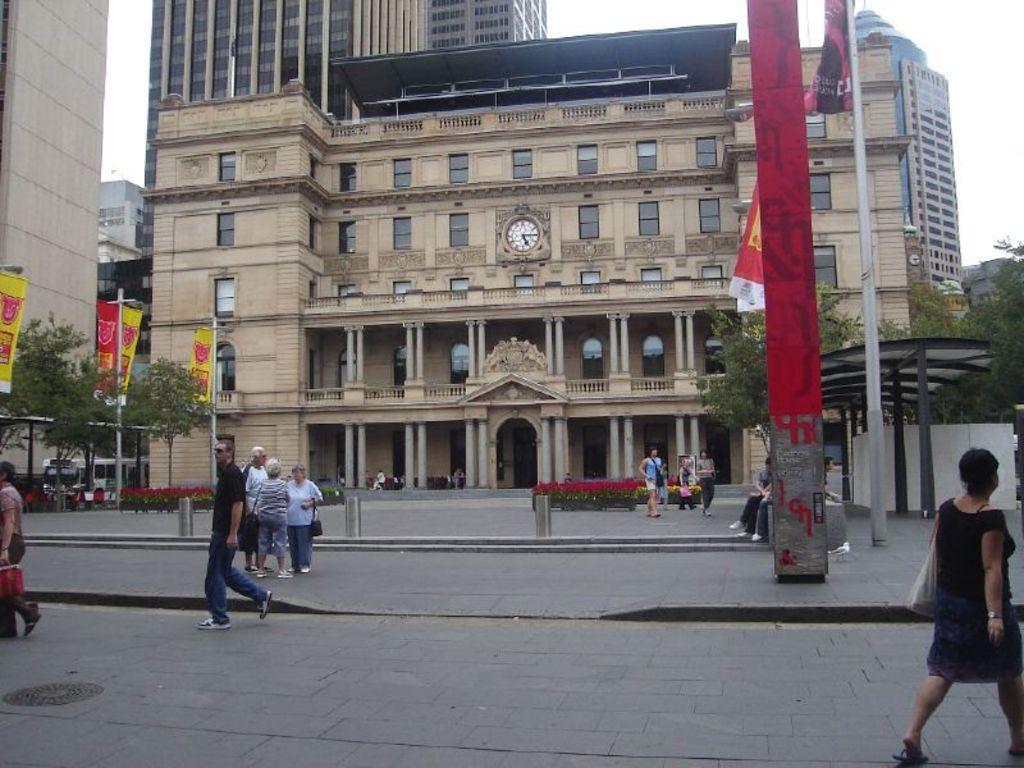How would you summarize this image in a sentence or two? As we can see in the image there are few people here and there, flag, plants, trees, banners and buildings. On the top there is sky. 